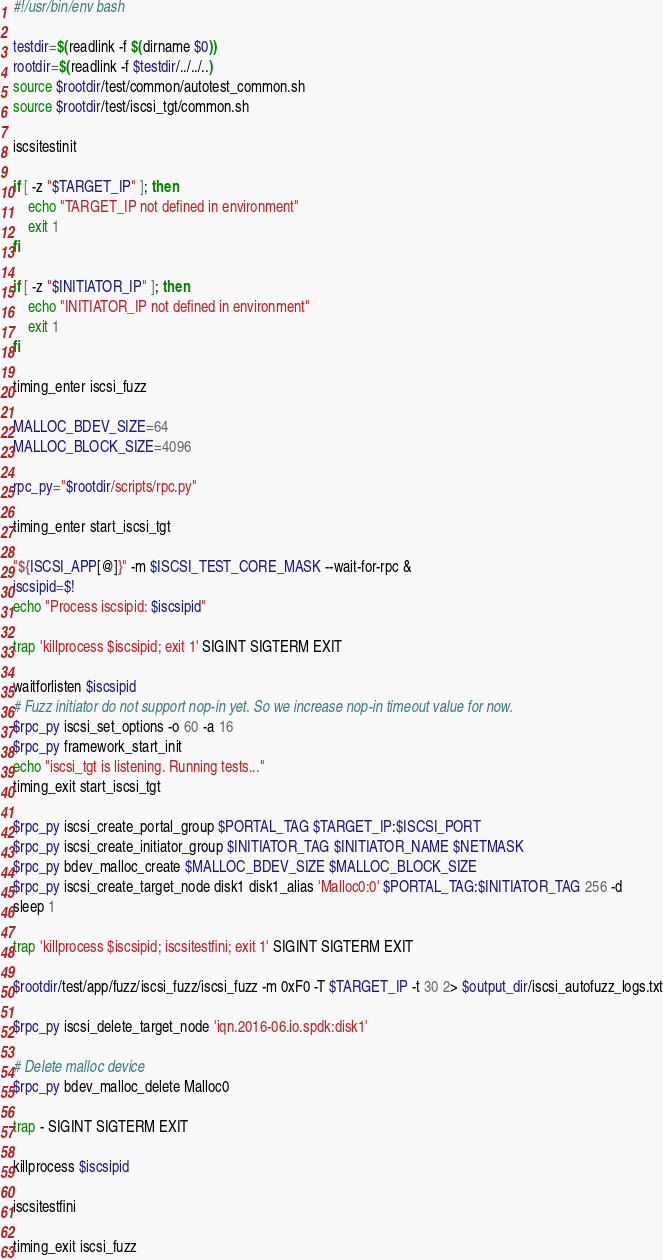<code> <loc_0><loc_0><loc_500><loc_500><_Bash_>#!/usr/bin/env bash

testdir=$(readlink -f $(dirname $0))
rootdir=$(readlink -f $testdir/../../..)
source $rootdir/test/common/autotest_common.sh
source $rootdir/test/iscsi_tgt/common.sh

iscsitestinit

if [ -z "$TARGET_IP" ]; then
	echo "TARGET_IP not defined in environment"
	exit 1
fi

if [ -z "$INITIATOR_IP" ]; then
	echo "INITIATOR_IP not defined in environment"
	exit 1
fi

timing_enter iscsi_fuzz

MALLOC_BDEV_SIZE=64
MALLOC_BLOCK_SIZE=4096

rpc_py="$rootdir/scripts/rpc.py"

timing_enter start_iscsi_tgt

"${ISCSI_APP[@]}" -m $ISCSI_TEST_CORE_MASK --wait-for-rpc &
iscsipid=$!
echo "Process iscsipid: $iscsipid"

trap 'killprocess $iscsipid; exit 1' SIGINT SIGTERM EXIT

waitforlisten $iscsipid
# Fuzz initiator do not support nop-in yet. So we increase nop-in timeout value for now.
$rpc_py iscsi_set_options -o 60 -a 16
$rpc_py framework_start_init
echo "iscsi_tgt is listening. Running tests..."
timing_exit start_iscsi_tgt

$rpc_py iscsi_create_portal_group $PORTAL_TAG $TARGET_IP:$ISCSI_PORT
$rpc_py iscsi_create_initiator_group $INITIATOR_TAG $INITIATOR_NAME $NETMASK
$rpc_py bdev_malloc_create $MALLOC_BDEV_SIZE $MALLOC_BLOCK_SIZE
$rpc_py iscsi_create_target_node disk1 disk1_alias 'Malloc0:0' $PORTAL_TAG:$INITIATOR_TAG 256 -d
sleep 1

trap 'killprocess $iscsipid; iscsitestfini; exit 1' SIGINT SIGTERM EXIT

$rootdir/test/app/fuzz/iscsi_fuzz/iscsi_fuzz -m 0xF0 -T $TARGET_IP -t 30 2> $output_dir/iscsi_autofuzz_logs.txt

$rpc_py iscsi_delete_target_node 'iqn.2016-06.io.spdk:disk1'

# Delete malloc device
$rpc_py bdev_malloc_delete Malloc0

trap - SIGINT SIGTERM EXIT

killprocess $iscsipid

iscsitestfini

timing_exit iscsi_fuzz
</code> 